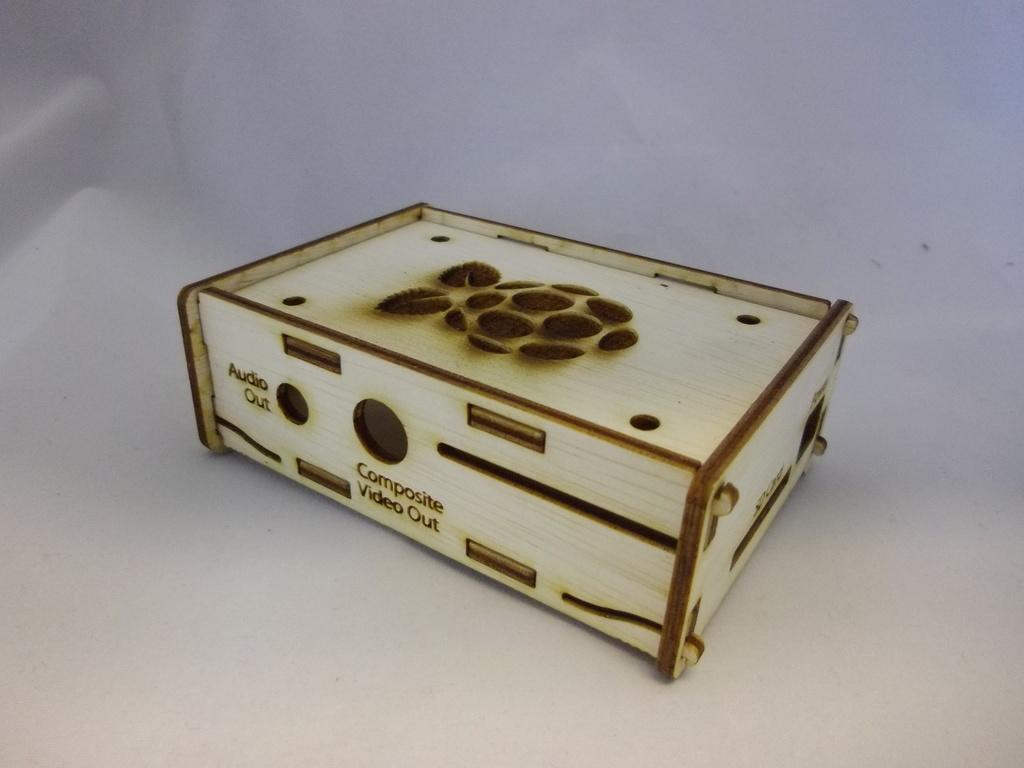<image>
Create a compact narrative representing the image presented. a wooden box has a place for audio out and composite out 